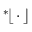<formula> <loc_0><loc_0><loc_500><loc_500>{ } ^ { * } \, \lfloor \, \cdot \, \rfloor</formula> 